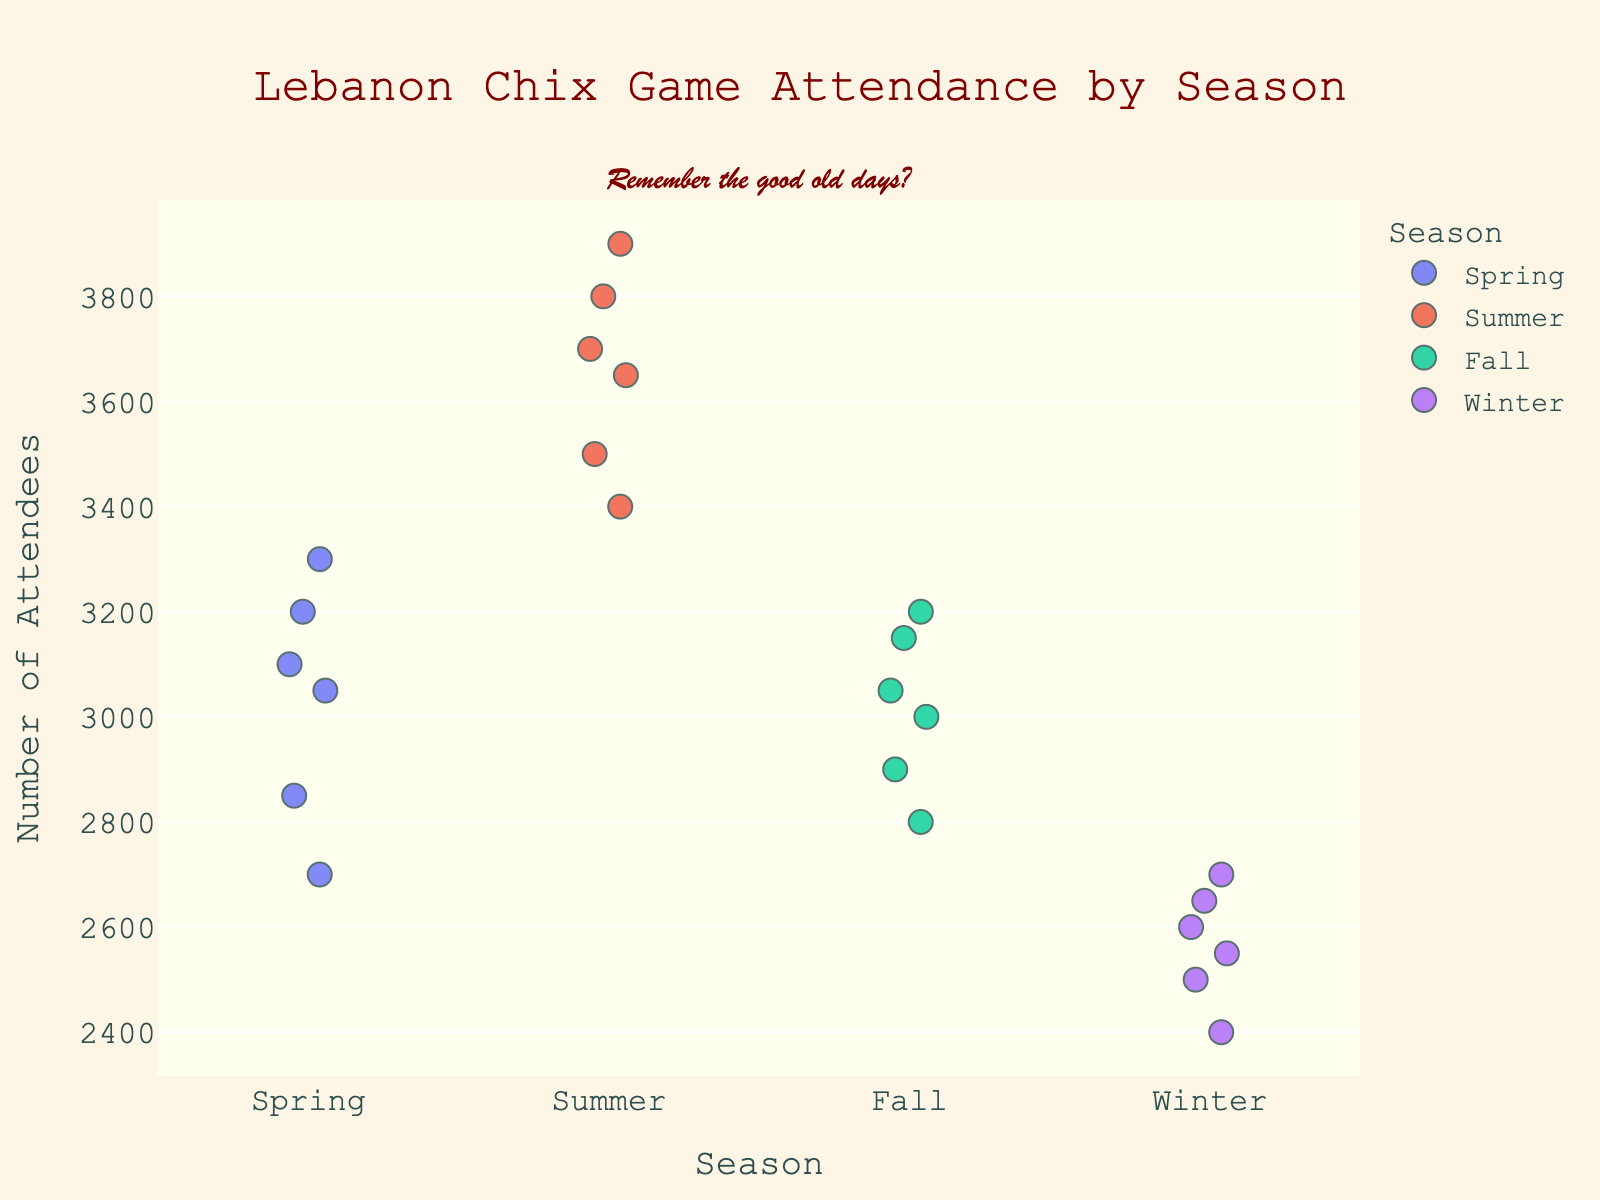How many seasons are represented in the plot? There are four distinct categories along the x-axis labeled "Spring," "Summer," "Fall," and "Winter." Each category represents a different season.
Answer: 4 What is the highest attendance figure for any Lebanon Chix game represented in the plot? The dots representing each game date are plotted on a common scale with the highest y-coordinate reaching 3900.
Answer: 3900 Which season had the highest average attendance figures, Spring or Fall? To find the average, sum the attendance figures for each season and divide by the number of entries. For Spring (1955-1956): (2850+3100+2700+3200+3050+3300)/6 = 3033.33. For Fall (1959-1960): (3200+3000+3150+2900+3050+2800)/6 = 3016.67. Comparing the two, Spring has a slightly higher average.
Answer: Spring Which season shows the most variation in attendance figures? Observe the spread of the data points in the vertical direction. Summer has the largest spread, with attendance figures ranging from 3400 to 3900, indicating the most variation.
Answer: Summer What is the attendance range for Winter games? Identify the lowest and highest attendance figures in Winter by spotting the uppermost and lowermost positions: from 2400 to 2700. The range is 2700 - 2400 = 300.
Answer: 300 Which year has the most data points represented in the plot? Count the number of data points for each year. 1955 has three data points, 1956 has three, 1957 has three, 1958 has three, 1959 has three, 1960 has three, 1961 has three, and 1962 has three. Therefore, each year has equal representation with three data points each.
Answer: Equal across all years Was the game attendance consistently higher in the Summer of 1958 compared to the Winter of 1961? For Summer 1958, the attendance figures are 3800, 3700, and 3900. For Winter 1961, attendances are 2500, 2400, and 2600. Summarizing, all summer attendance figures (3700, 3800, 3900) are higher compared to the winter figures (2400, 2500, 2600).
Answer: Yes Which season has the most tightly clustered attendance figures? By assessing the visual spread of the data points along the y-axis per season, Winter displays the most tightly clustered points ranging narrowly from 2400 to 2700.
Answer: Winter 